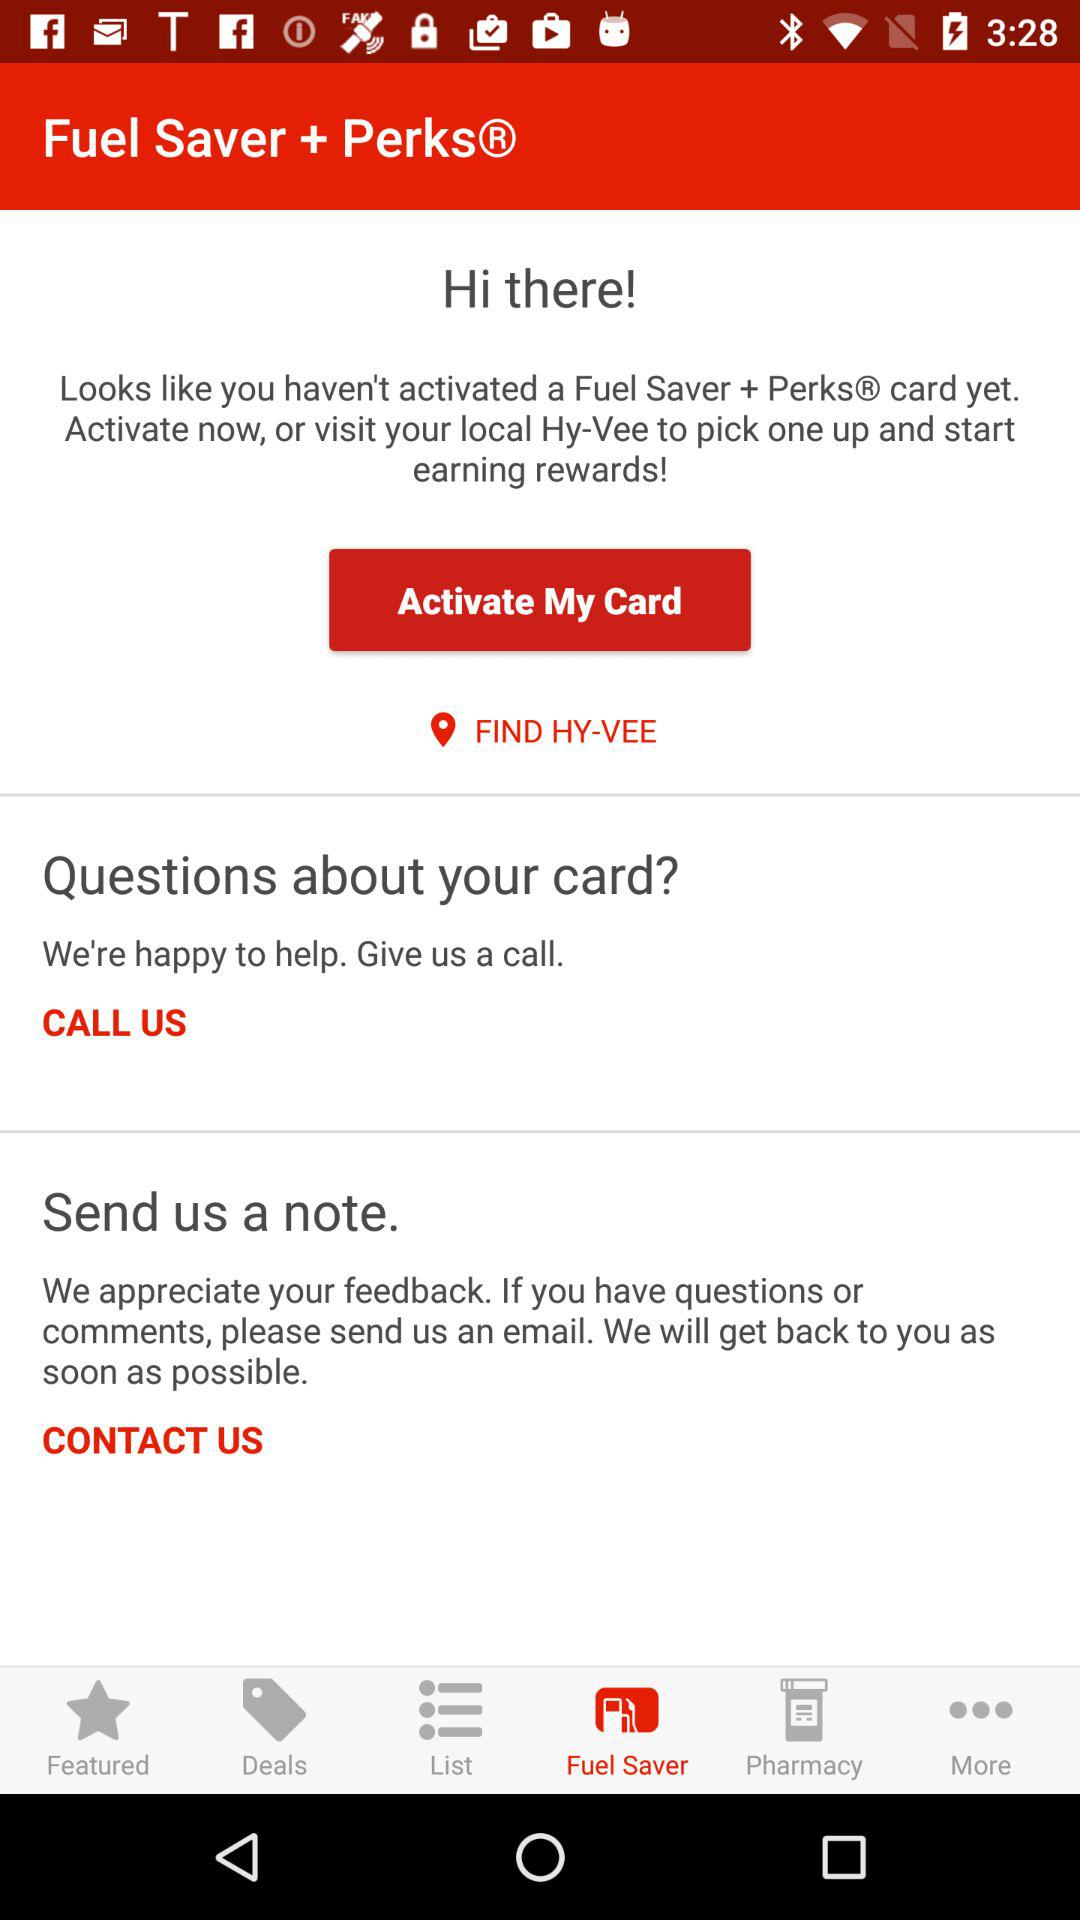How can we reach to ask question? You can reach via email. 